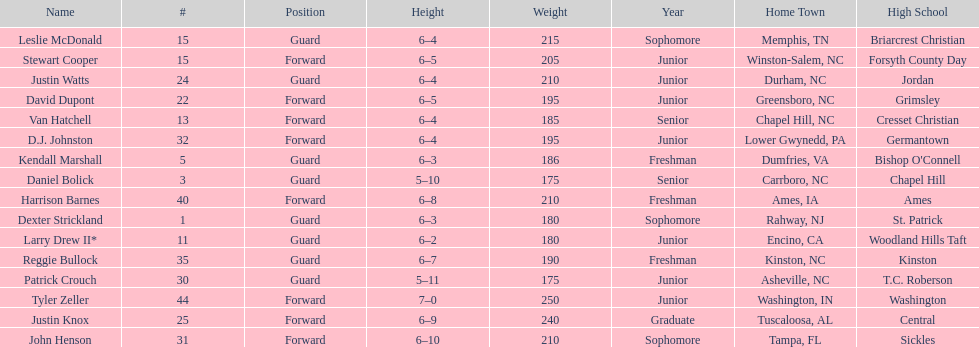What was the number of freshmen on the team? 3. 